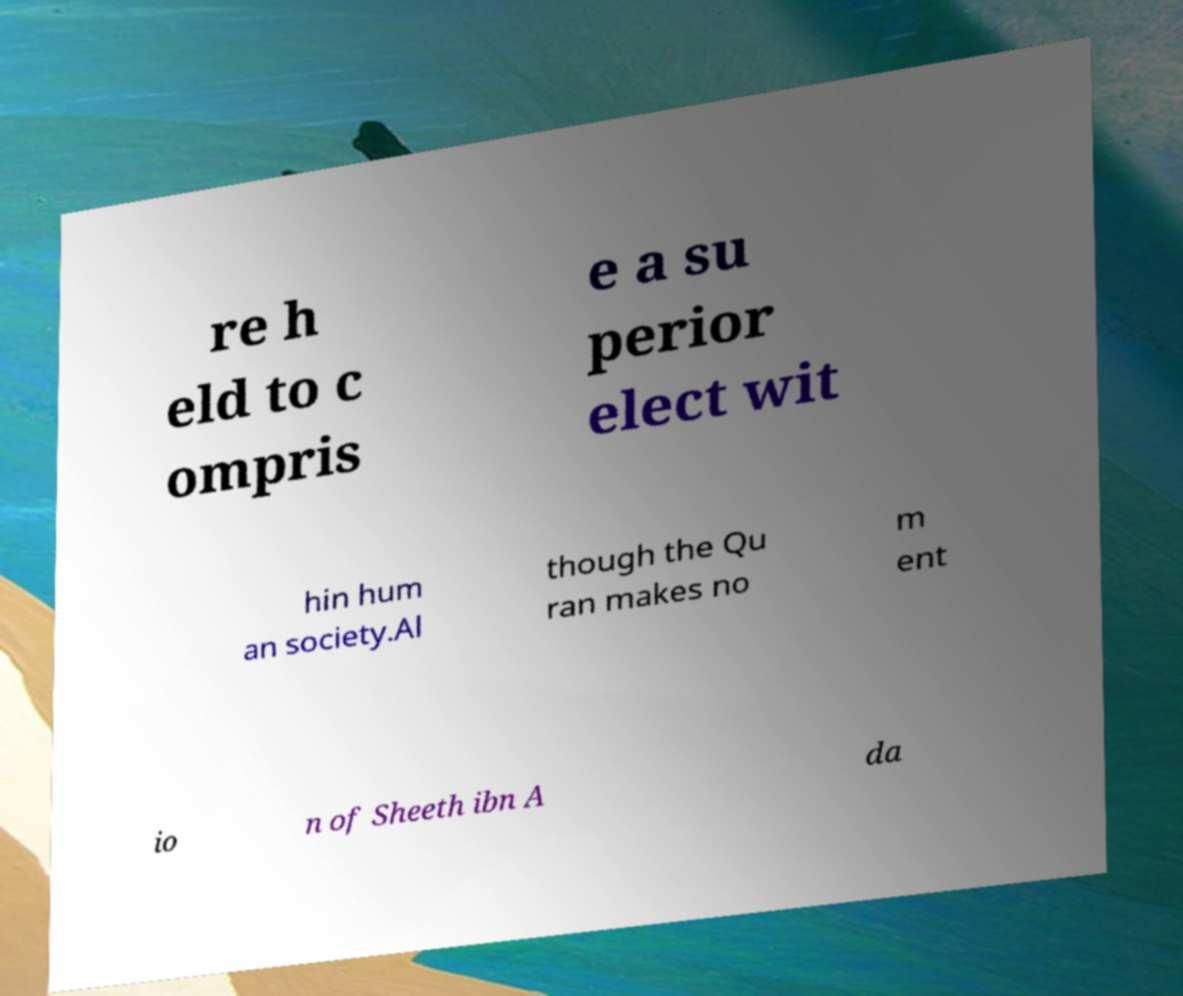For documentation purposes, I need the text within this image transcribed. Could you provide that? re h eld to c ompris e a su perior elect wit hin hum an society.Al though the Qu ran makes no m ent io n of Sheeth ibn A da 